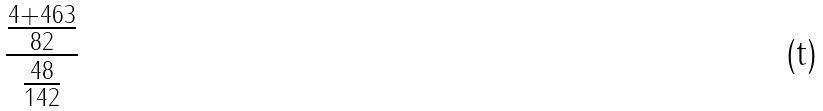Convert formula to latex. <formula><loc_0><loc_0><loc_500><loc_500>\frac { \frac { 4 + 4 6 3 } { 8 2 } } { \frac { 4 8 } { 1 4 2 } }</formula> 